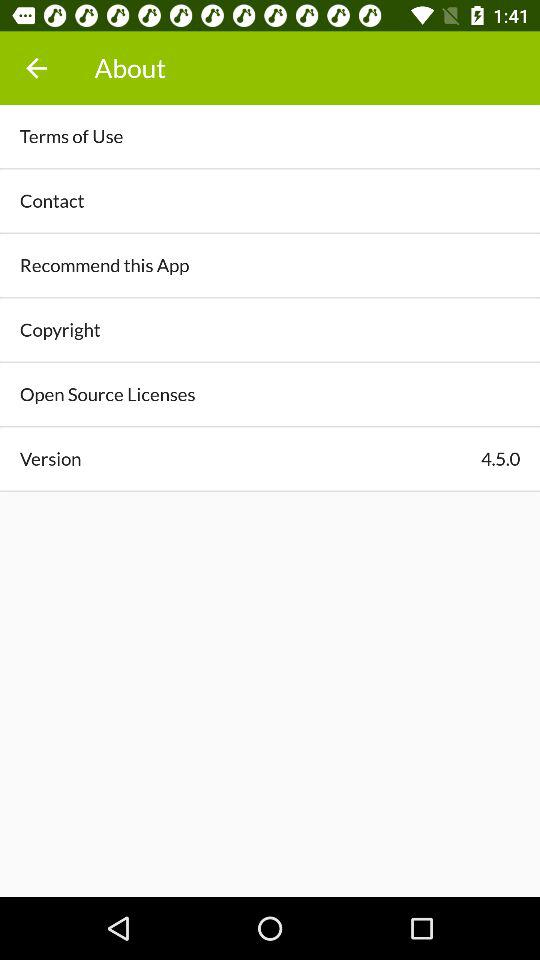What is the version of the app? The version of the app is 4.5.0. 